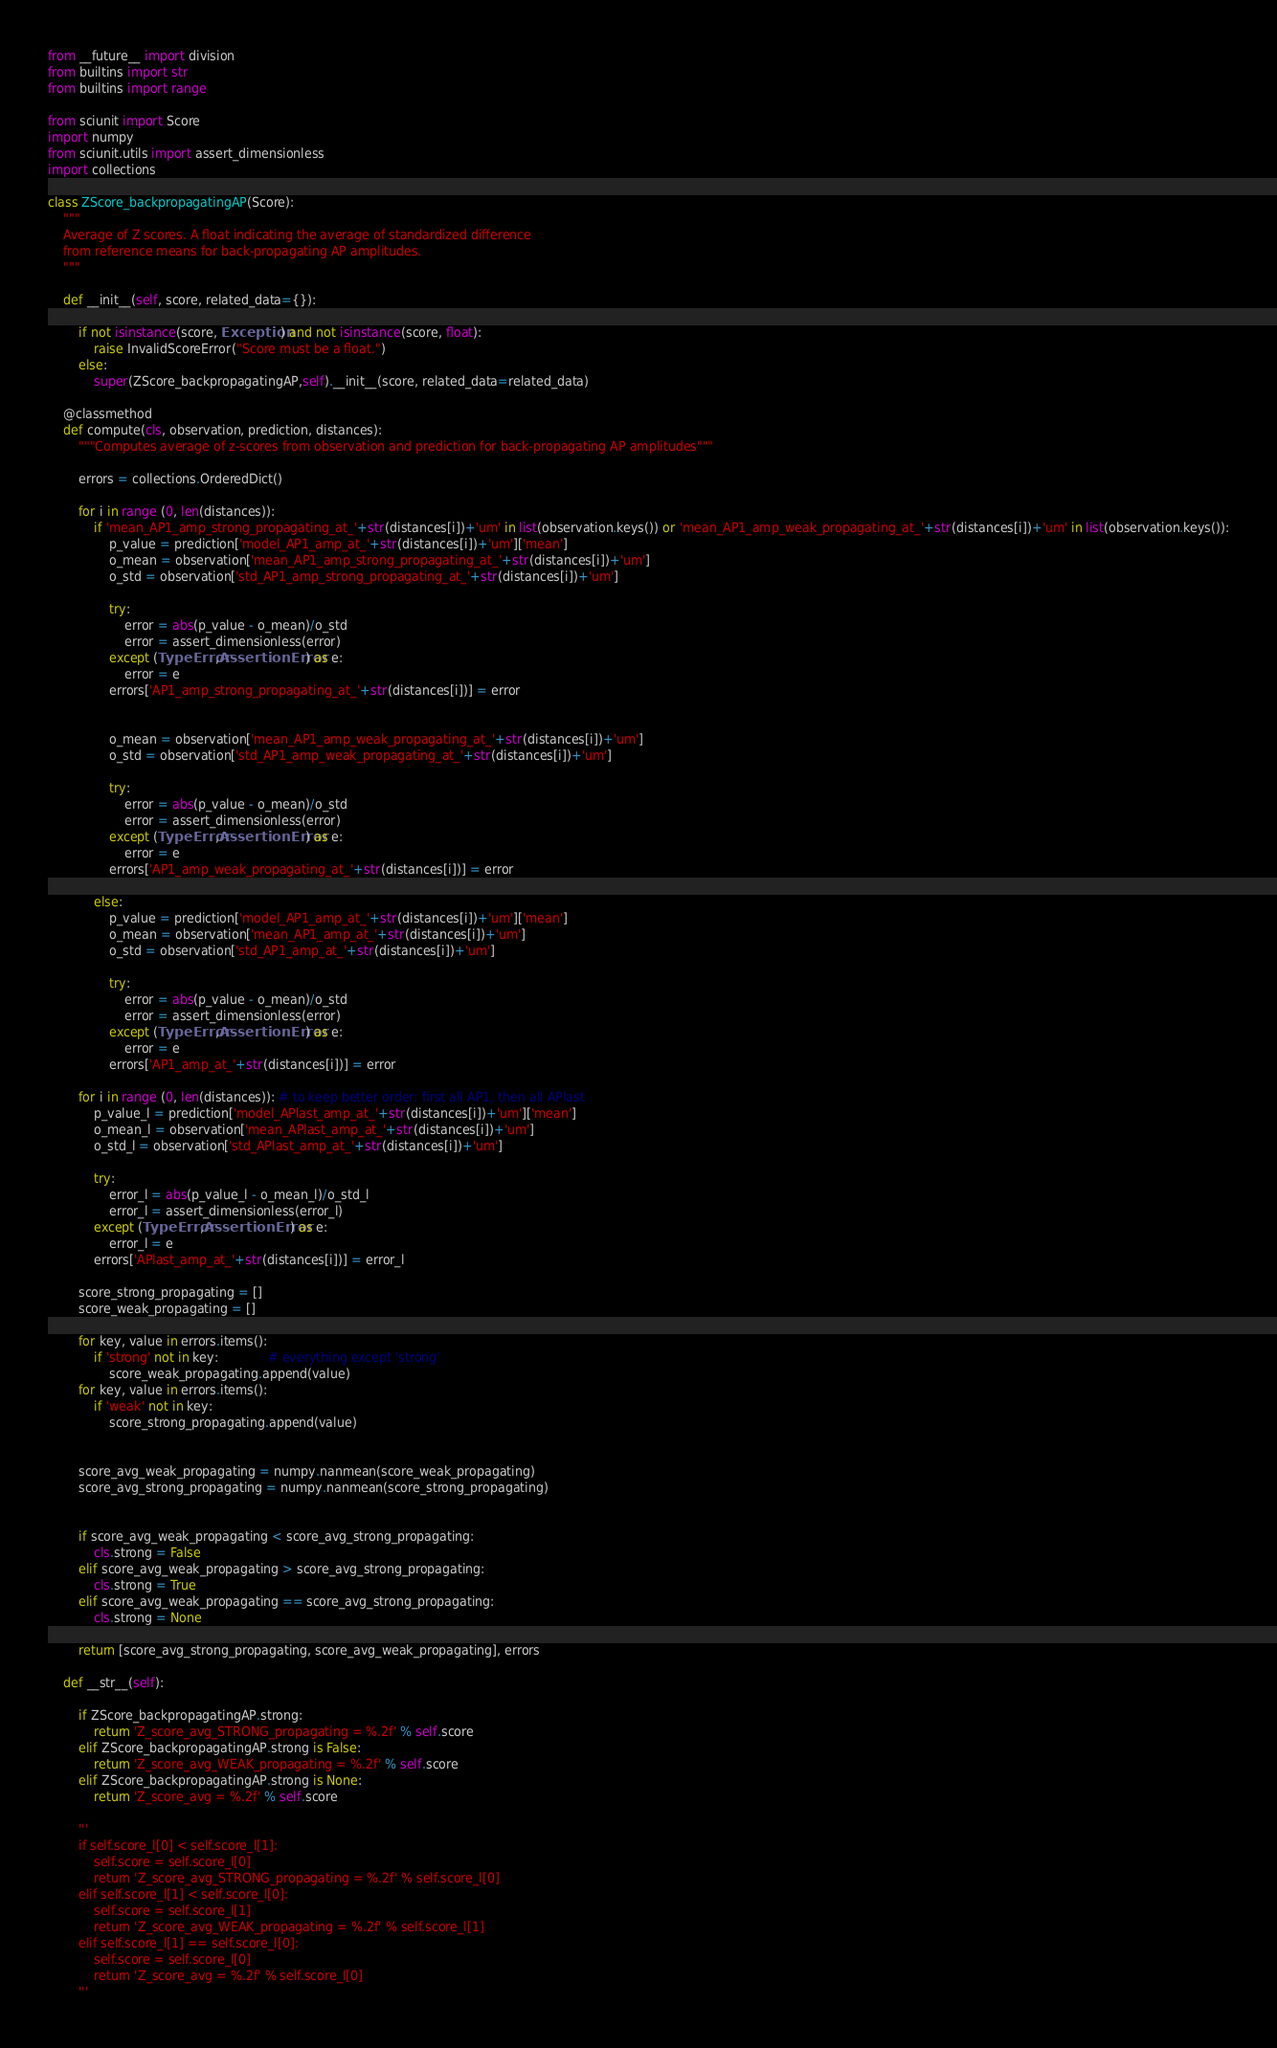<code> <loc_0><loc_0><loc_500><loc_500><_Python_>from __future__ import division
from builtins import str
from builtins import range

from sciunit import Score
import numpy
from sciunit.utils import assert_dimensionless
import collections

class ZScore_backpropagatingAP(Score):
    """
    Average of Z scores. A float indicating the average of standardized difference
    from reference means for back-propagating AP amplitudes.
    """

    def __init__(self, score, related_data={}):

        if not isinstance(score, Exception) and not isinstance(score, float):
            raise InvalidScoreError("Score must be a float.")
        else:
            super(ZScore_backpropagatingAP,self).__init__(score, related_data=related_data)

    @classmethod
    def compute(cls, observation, prediction, distances):
        """Computes average of z-scores from observation and prediction for back-propagating AP amplitudes"""

        errors = collections.OrderedDict()

        for i in range (0, len(distances)):
            if 'mean_AP1_amp_strong_propagating_at_'+str(distances[i])+'um' in list(observation.keys()) or 'mean_AP1_amp_weak_propagating_at_'+str(distances[i])+'um' in list(observation.keys()):
                p_value = prediction['model_AP1_amp_at_'+str(distances[i])+'um']['mean']
                o_mean = observation['mean_AP1_amp_strong_propagating_at_'+str(distances[i])+'um']
                o_std = observation['std_AP1_amp_strong_propagating_at_'+str(distances[i])+'um']

                try:
                    error = abs(p_value - o_mean)/o_std
                    error = assert_dimensionless(error)
                except (TypeError,AssertionError) as e:
                    error = e
                errors['AP1_amp_strong_propagating_at_'+str(distances[i])] = error


                o_mean = observation['mean_AP1_amp_weak_propagating_at_'+str(distances[i])+'um']
                o_std = observation['std_AP1_amp_weak_propagating_at_'+str(distances[i])+'um']

                try:
                    error = abs(p_value - o_mean)/o_std
                    error = assert_dimensionless(error)
                except (TypeError,AssertionError) as e:
                    error = e
                errors['AP1_amp_weak_propagating_at_'+str(distances[i])] = error

            else:
                p_value = prediction['model_AP1_amp_at_'+str(distances[i])+'um']['mean']
                o_mean = observation['mean_AP1_amp_at_'+str(distances[i])+'um']
                o_std = observation['std_AP1_amp_at_'+str(distances[i])+'um']

                try:
                    error = abs(p_value - o_mean)/o_std
                    error = assert_dimensionless(error)
                except (TypeError,AssertionError) as e:
                    error = e
                errors['AP1_amp_at_'+str(distances[i])] = error

        for i in range (0, len(distances)): # to keep better order: first all AP1, then all APlast
            p_value_l = prediction['model_APlast_amp_at_'+str(distances[i])+'um']['mean']
            o_mean_l = observation['mean_APlast_amp_at_'+str(distances[i])+'um']
            o_std_l = observation['std_APlast_amp_at_'+str(distances[i])+'um']

            try:
                error_l = abs(p_value_l - o_mean_l)/o_std_l
                error_l = assert_dimensionless(error_l)
            except (TypeError,AssertionError) as e:
                error_l = e
            errors['APlast_amp_at_'+str(distances[i])] = error_l

        score_strong_propagating = []
        score_weak_propagating = []

        for key, value in errors.items():
            if 'strong' not in key:             # everything except 'strong'
                score_weak_propagating.append(value)
        for key, value in errors.items():
            if 'weak' not in key:
                score_strong_propagating.append(value)


        score_avg_weak_propagating = numpy.nanmean(score_weak_propagating)
        score_avg_strong_propagating = numpy.nanmean(score_strong_propagating)


        if score_avg_weak_propagating < score_avg_strong_propagating:
            cls.strong = False
        elif score_avg_weak_propagating > score_avg_strong_propagating:
            cls.strong = True
        elif score_avg_weak_propagating == score_avg_strong_propagating:
            cls.strong = None

        return [score_avg_strong_propagating, score_avg_weak_propagating], errors

    def __str__(self):

        if ZScore_backpropagatingAP.strong:
            return 'Z_score_avg_STRONG_propagating = %.2f' % self.score
        elif ZScore_backpropagatingAP.strong is False:
            return 'Z_score_avg_WEAK_propagating = %.2f' % self.score
        elif ZScore_backpropagatingAP.strong is None:
            return 'Z_score_avg = %.2f' % self.score

        '''
        if self.score_l[0] < self.score_l[1]:
            self.score = self.score_l[0]
            return 'Z_score_avg_STRONG_propagating = %.2f' % self.score_l[0]
        elif self.score_l[1] < self.score_l[0]:
            self.score = self.score_l[1]
            return 'Z_score_avg_WEAK_propagating = %.2f' % self.score_l[1]
        elif self.score_l[1] == self.score_l[0]:
            self.score = self.score_l[0]
            return 'Z_score_avg = %.2f' % self.score_l[0]
        '''
</code> 